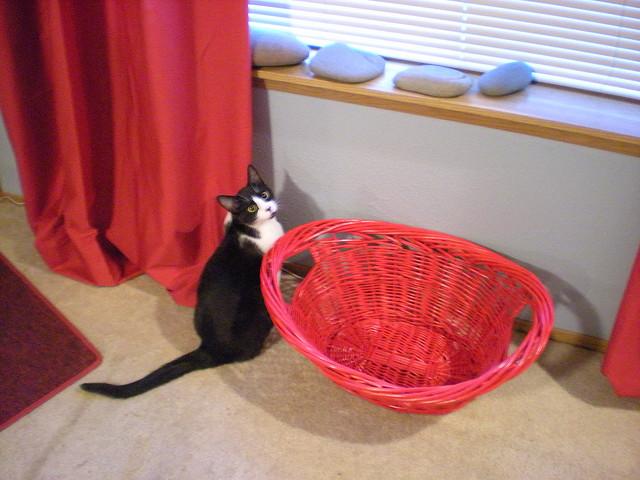How many objects are on the windowsill?
Write a very short answer. 4. What is the color of the cat?
Quick response, please. Black and white. Is he in a basket?
Quick response, please. No. 